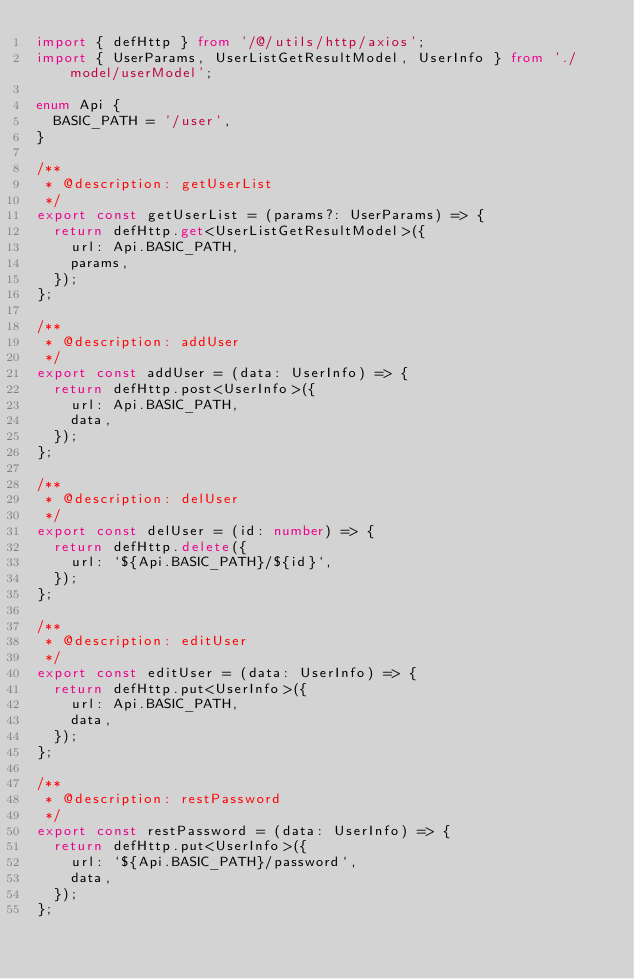<code> <loc_0><loc_0><loc_500><loc_500><_TypeScript_>import { defHttp } from '/@/utils/http/axios';
import { UserParams, UserListGetResultModel, UserInfo } from './model/userModel';

enum Api {
  BASIC_PATH = '/user',
}

/**
 * @description: getUserList
 */
export const getUserList = (params?: UserParams) => {
  return defHttp.get<UserListGetResultModel>({
    url: Api.BASIC_PATH,
    params,
  });
};

/**
 * @description: addUser
 */
export const addUser = (data: UserInfo) => {
  return defHttp.post<UserInfo>({
    url: Api.BASIC_PATH,
    data,
  });
};

/**
 * @description: delUser
 */
export const delUser = (id: number) => {
  return defHttp.delete({
    url: `${Api.BASIC_PATH}/${id}`,
  });
};

/**
 * @description: editUser
 */
export const editUser = (data: UserInfo) => {
  return defHttp.put<UserInfo>({
    url: Api.BASIC_PATH,
    data,
  });
};

/**
 * @description: restPassword
 */
export const restPassword = (data: UserInfo) => {
  return defHttp.put<UserInfo>({
    url: `${Api.BASIC_PATH}/password`,
    data,
  });
};
</code> 